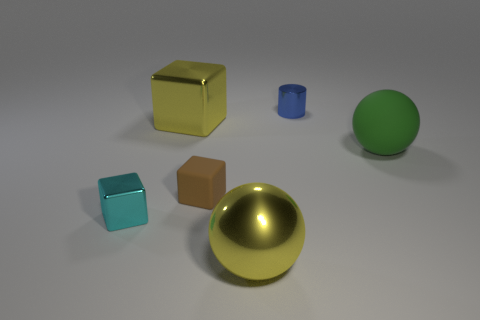Subtract all shiny blocks. How many blocks are left? 1 Add 2 large yellow spheres. How many objects exist? 8 Subtract all cylinders. How many objects are left? 5 Subtract all large yellow balls. Subtract all big red metal cylinders. How many objects are left? 5 Add 4 cylinders. How many cylinders are left? 5 Add 2 small blue shiny objects. How many small blue shiny objects exist? 3 Subtract 0 blue blocks. How many objects are left? 6 